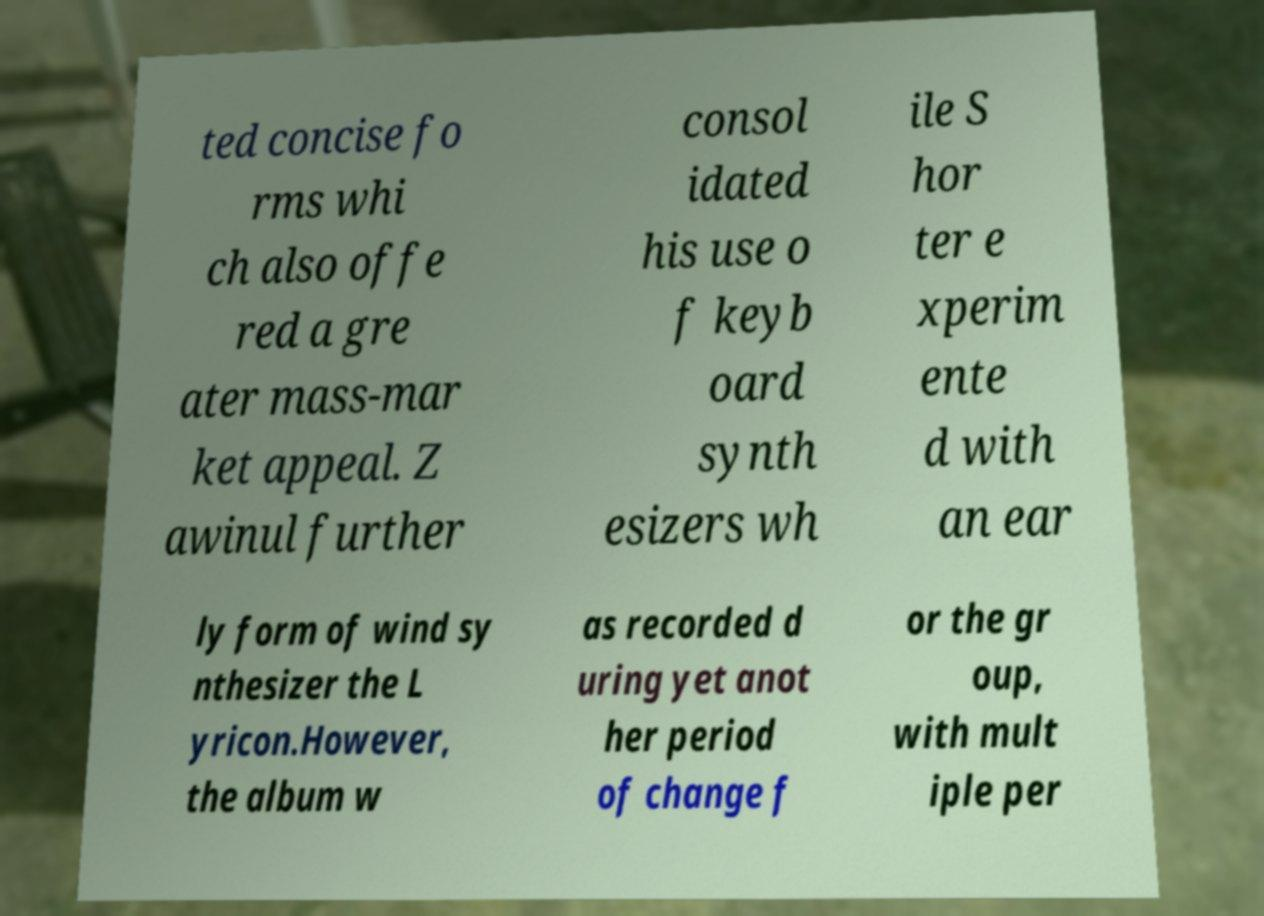What messages or text are displayed in this image? I need them in a readable, typed format. ted concise fo rms whi ch also offe red a gre ater mass-mar ket appeal. Z awinul further consol idated his use o f keyb oard synth esizers wh ile S hor ter e xperim ente d with an ear ly form of wind sy nthesizer the L yricon.However, the album w as recorded d uring yet anot her period of change f or the gr oup, with mult iple per 